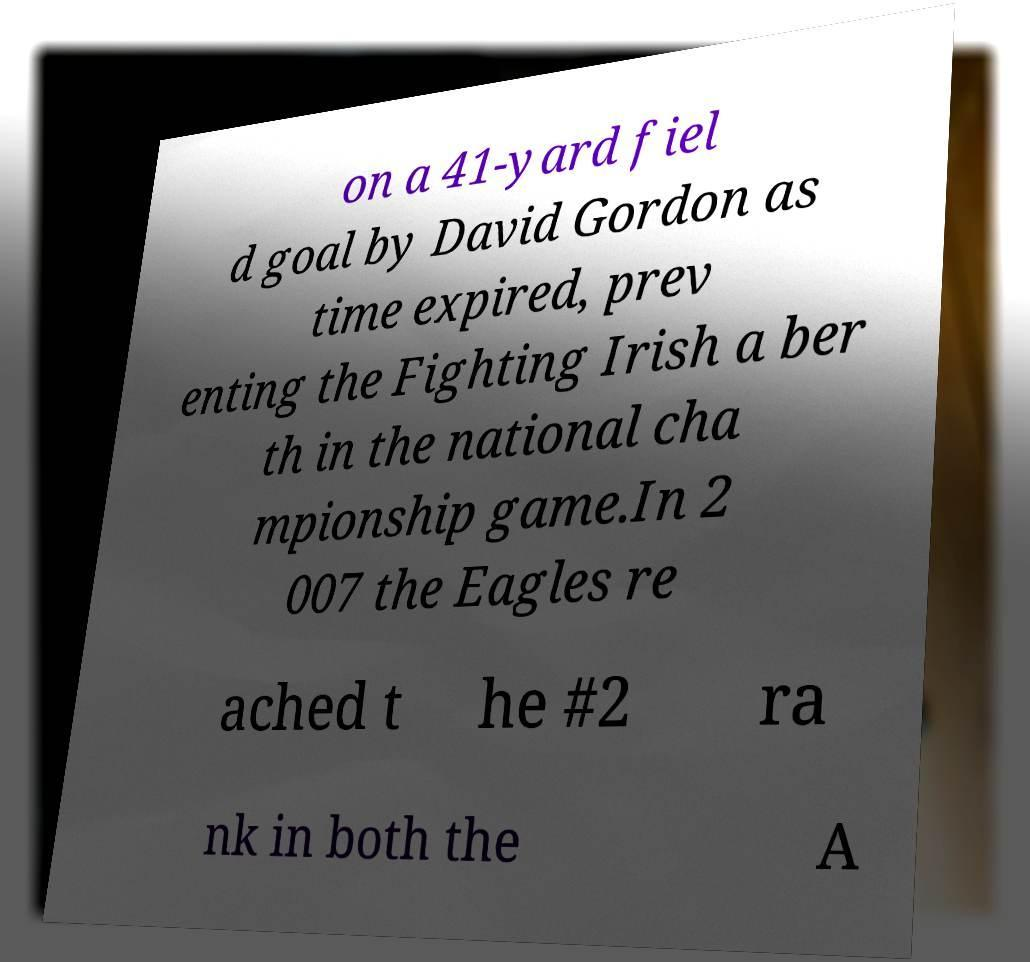What messages or text are displayed in this image? I need them in a readable, typed format. on a 41-yard fiel d goal by David Gordon as time expired, prev enting the Fighting Irish a ber th in the national cha mpionship game.In 2 007 the Eagles re ached t he #2 ra nk in both the A 